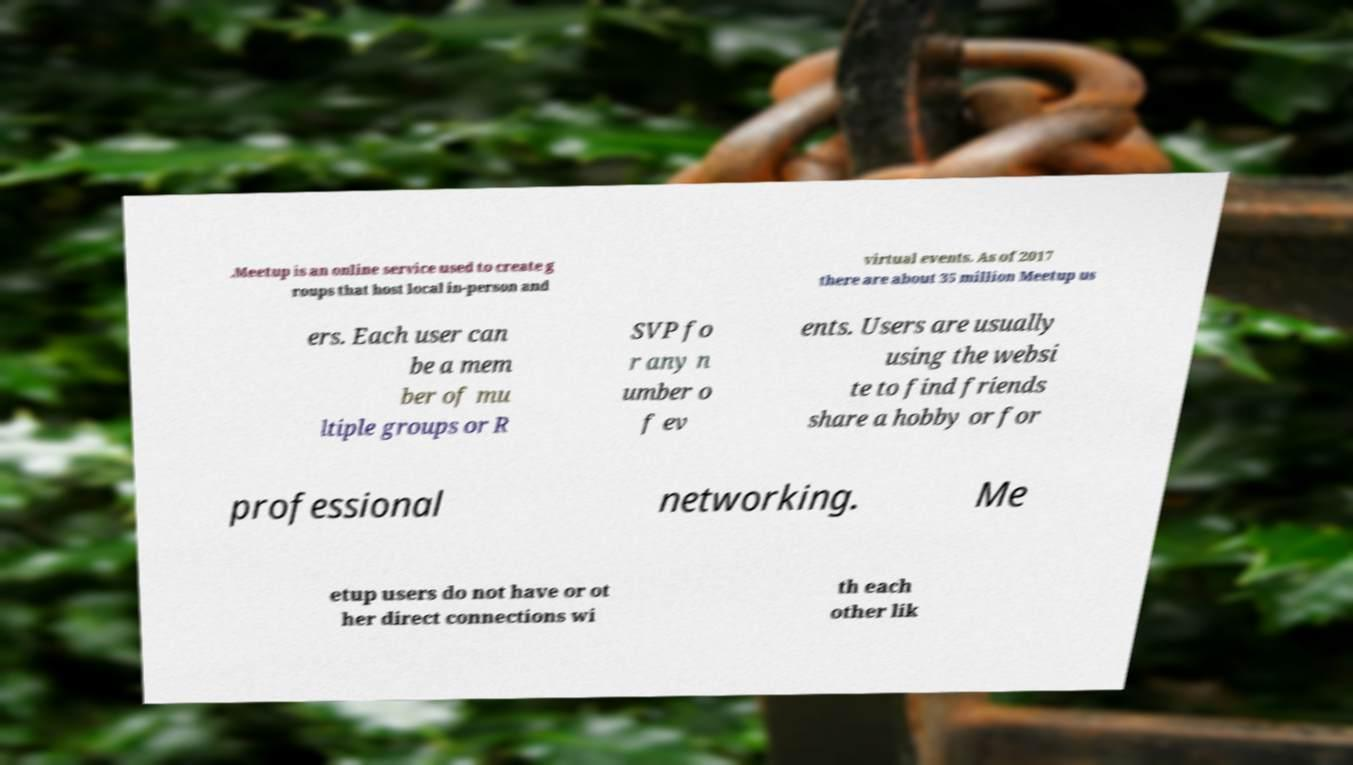Can you read and provide the text displayed in the image?This photo seems to have some interesting text. Can you extract and type it out for me? .Meetup is an online service used to create g roups that host local in-person and virtual events. As of 2017 there are about 35 million Meetup us ers. Each user can be a mem ber of mu ltiple groups or R SVP fo r any n umber o f ev ents. Users are usually using the websi te to find friends share a hobby or for professional networking. Me etup users do not have or ot her direct connections wi th each other lik 